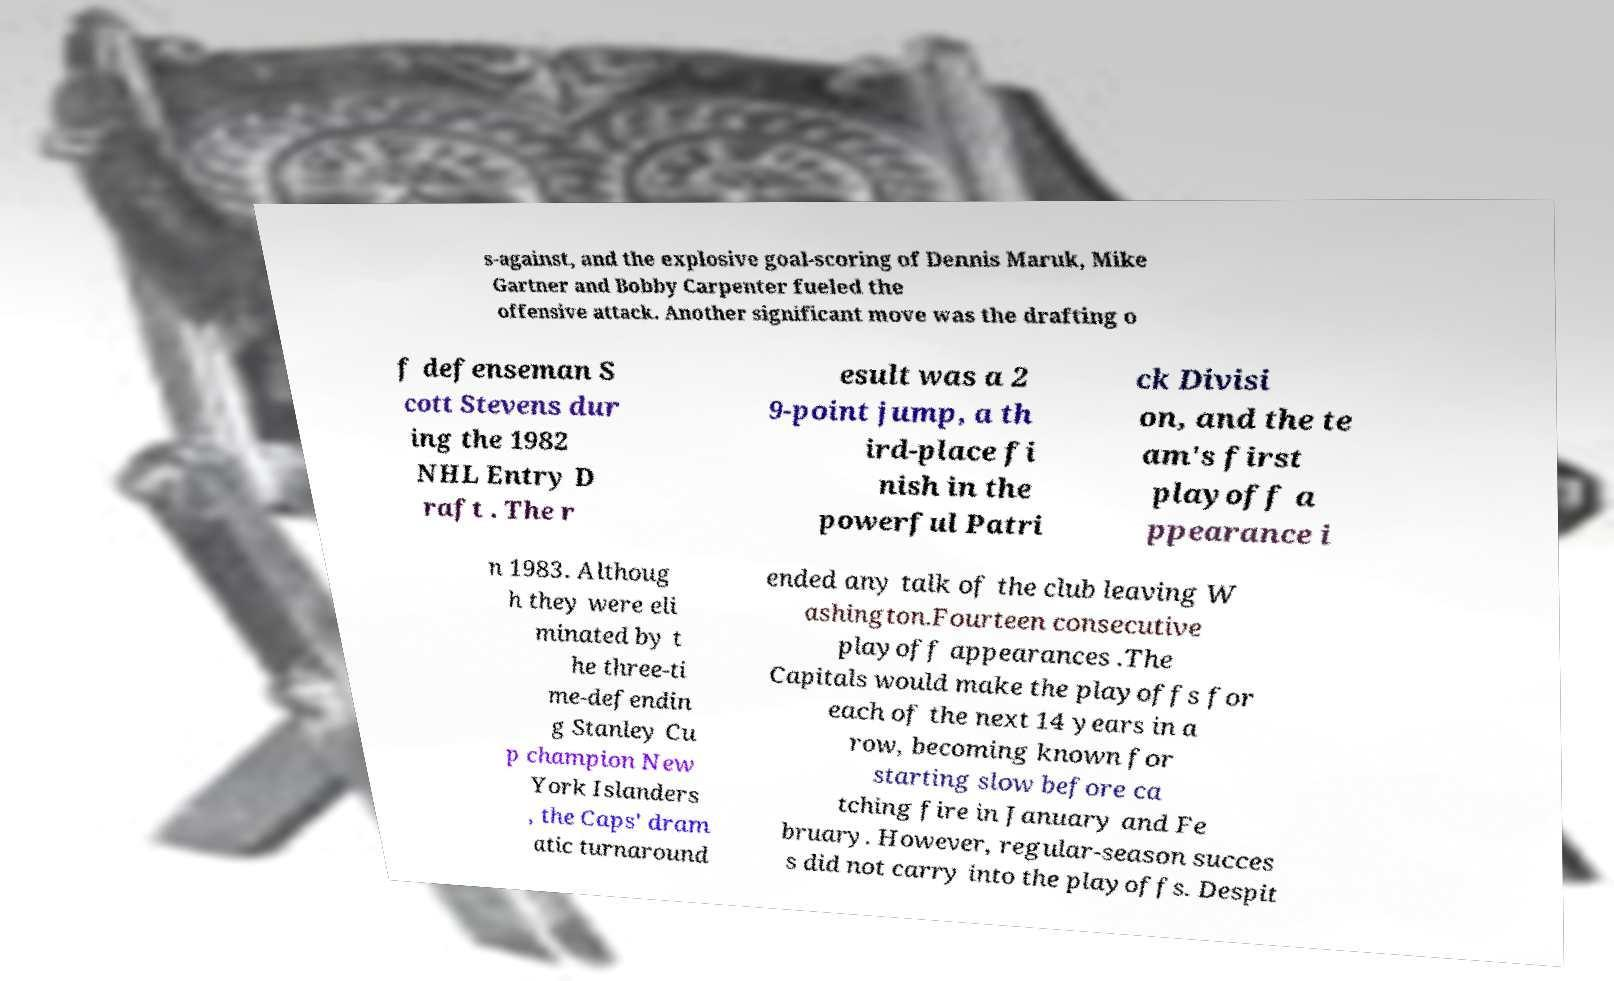Can you read and provide the text displayed in the image?This photo seems to have some interesting text. Can you extract and type it out for me? s-against, and the explosive goal-scoring of Dennis Maruk, Mike Gartner and Bobby Carpenter fueled the offensive attack. Another significant move was the drafting o f defenseman S cott Stevens dur ing the 1982 NHL Entry D raft . The r esult was a 2 9-point jump, a th ird-place fi nish in the powerful Patri ck Divisi on, and the te am's first playoff a ppearance i n 1983. Althoug h they were eli minated by t he three-ti me-defendin g Stanley Cu p champion New York Islanders , the Caps' dram atic turnaround ended any talk of the club leaving W ashington.Fourteen consecutive playoff appearances .The Capitals would make the playoffs for each of the next 14 years in a row, becoming known for starting slow before ca tching fire in January and Fe bruary. However, regular-season succes s did not carry into the playoffs. Despit 